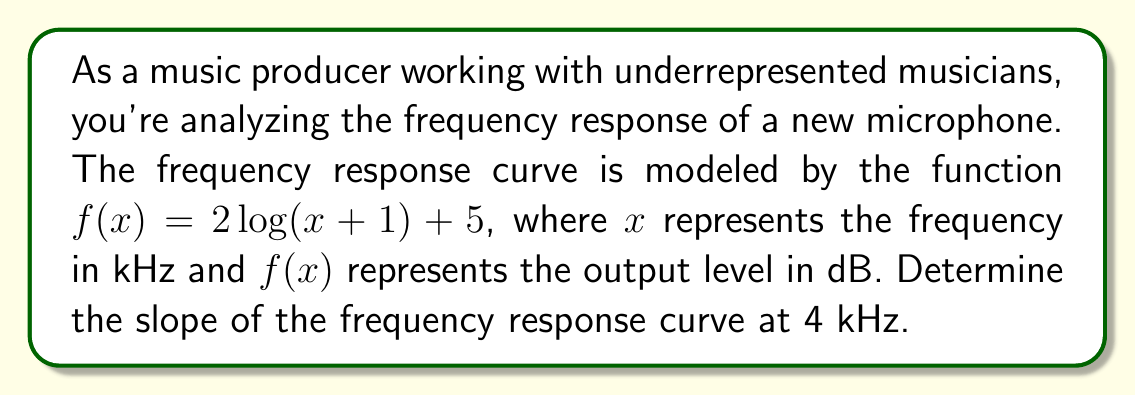Could you help me with this problem? To find the slope of the frequency response curve at a specific point, we need to calculate the derivative of the function and evaluate it at the given point. Let's follow these steps:

1) The given function is $f(x) = 2\log(x+1) + 5$

2) To find the derivative, we use the chain rule:
   $$f'(x) = 2 \cdot \frac{d}{dx}[\log(x+1)]$$

3) The derivative of $\log(x)$ is $\frac{1}{x}$, so:
   $$f'(x) = 2 \cdot \frac{1}{x+1}$$

4) Now we need to evaluate this at $x = 4$ (since we're looking at 4 kHz):
   $$f'(4) = 2 \cdot \frac{1}{4+1} = 2 \cdot \frac{1}{5} = \frac{2}{5} = 0.4$$

5) Therefore, the slope of the frequency response curve at 4 kHz is 0.4 dB/kHz.

This positive slope indicates that the microphone's output level is increasing as the frequency increases at this point, which could affect the tonal balance of the recorded audio.
Answer: 0.4 dB/kHz 